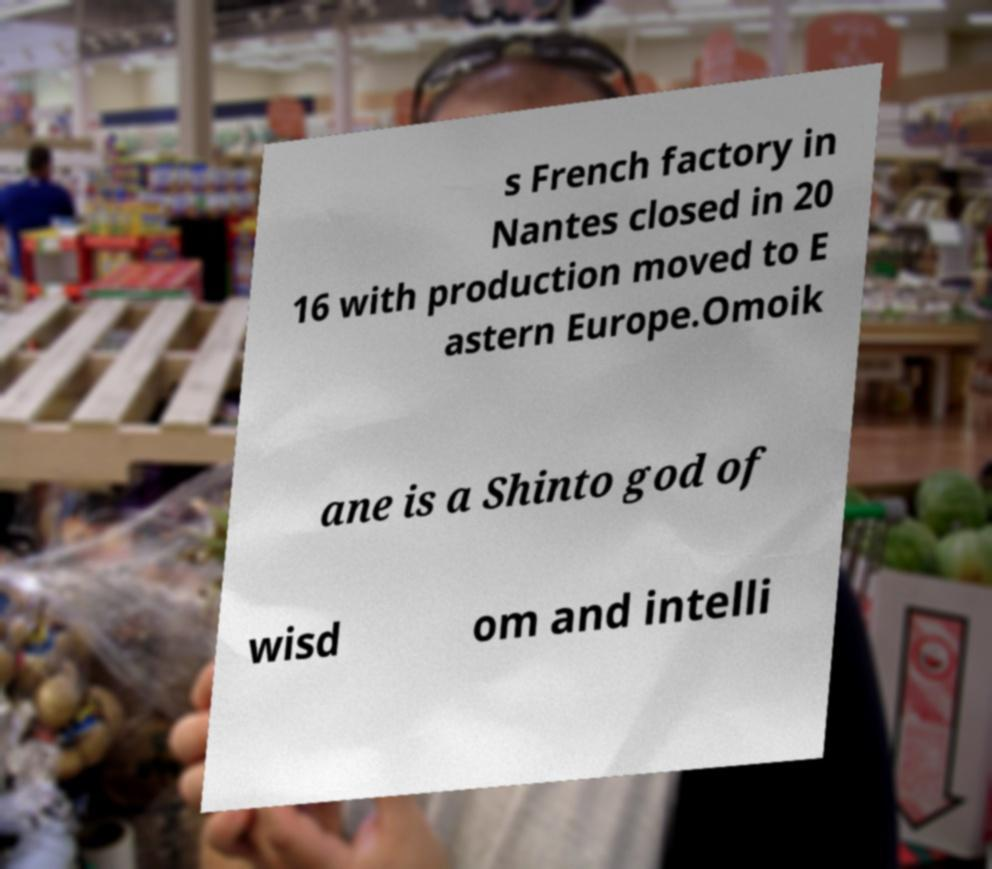Can you read and provide the text displayed in the image?This photo seems to have some interesting text. Can you extract and type it out for me? s French factory in Nantes closed in 20 16 with production moved to E astern Europe.Omoik ane is a Shinto god of wisd om and intelli 